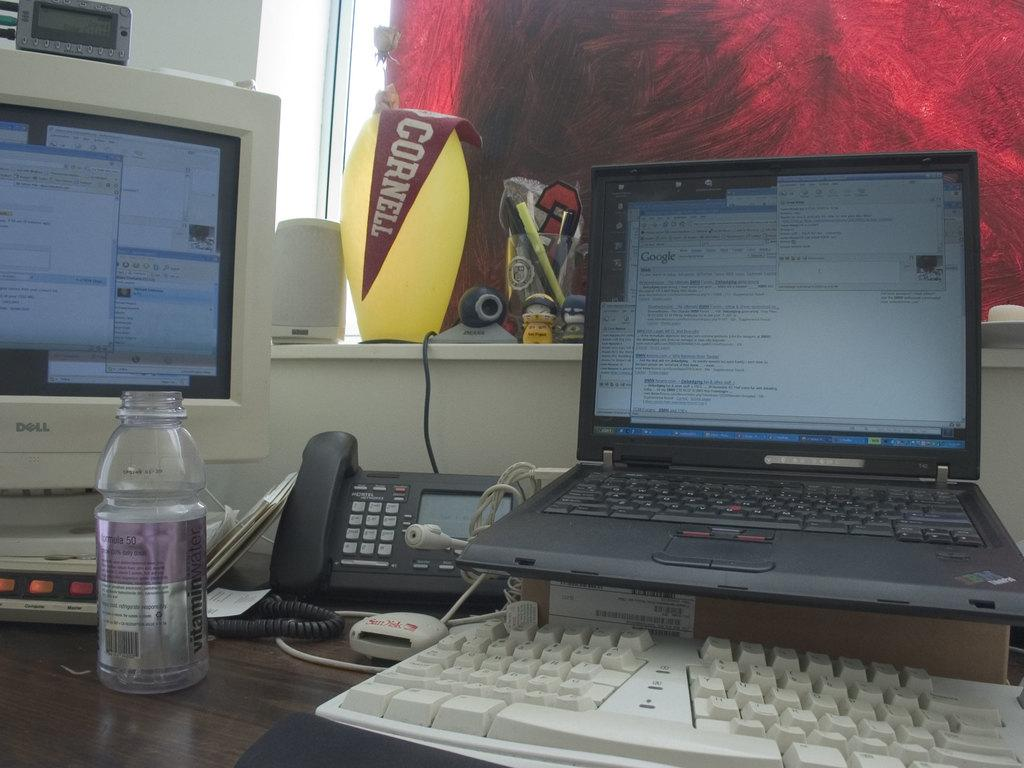<image>
Provide a brief description of the given image. a laptop and computer on a desk with a red "Cornell" banner sitting on a lamp on the windowsill 